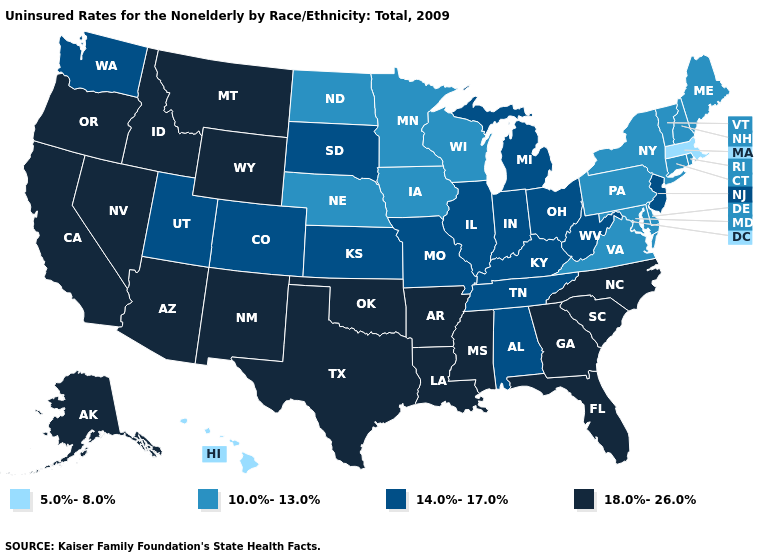Does Rhode Island have a higher value than Hawaii?
Answer briefly. Yes. Does Mississippi have the lowest value in the South?
Quick response, please. No. Among the states that border Kansas , which have the lowest value?
Be succinct. Nebraska. Among the states that border Texas , which have the highest value?
Be succinct. Arkansas, Louisiana, New Mexico, Oklahoma. Is the legend a continuous bar?
Short answer required. No. What is the highest value in the West ?
Answer briefly. 18.0%-26.0%. What is the highest value in states that border Texas?
Concise answer only. 18.0%-26.0%. Among the states that border California , which have the highest value?
Be succinct. Arizona, Nevada, Oregon. Name the states that have a value in the range 18.0%-26.0%?
Write a very short answer. Alaska, Arizona, Arkansas, California, Florida, Georgia, Idaho, Louisiana, Mississippi, Montana, Nevada, New Mexico, North Carolina, Oklahoma, Oregon, South Carolina, Texas, Wyoming. What is the highest value in the MidWest ?
Keep it brief. 14.0%-17.0%. What is the value of Indiana?
Give a very brief answer. 14.0%-17.0%. Name the states that have a value in the range 18.0%-26.0%?
Write a very short answer. Alaska, Arizona, Arkansas, California, Florida, Georgia, Idaho, Louisiana, Mississippi, Montana, Nevada, New Mexico, North Carolina, Oklahoma, Oregon, South Carolina, Texas, Wyoming. What is the value of Texas?
Give a very brief answer. 18.0%-26.0%. What is the highest value in the West ?
Give a very brief answer. 18.0%-26.0%. Does the map have missing data?
Write a very short answer. No. 